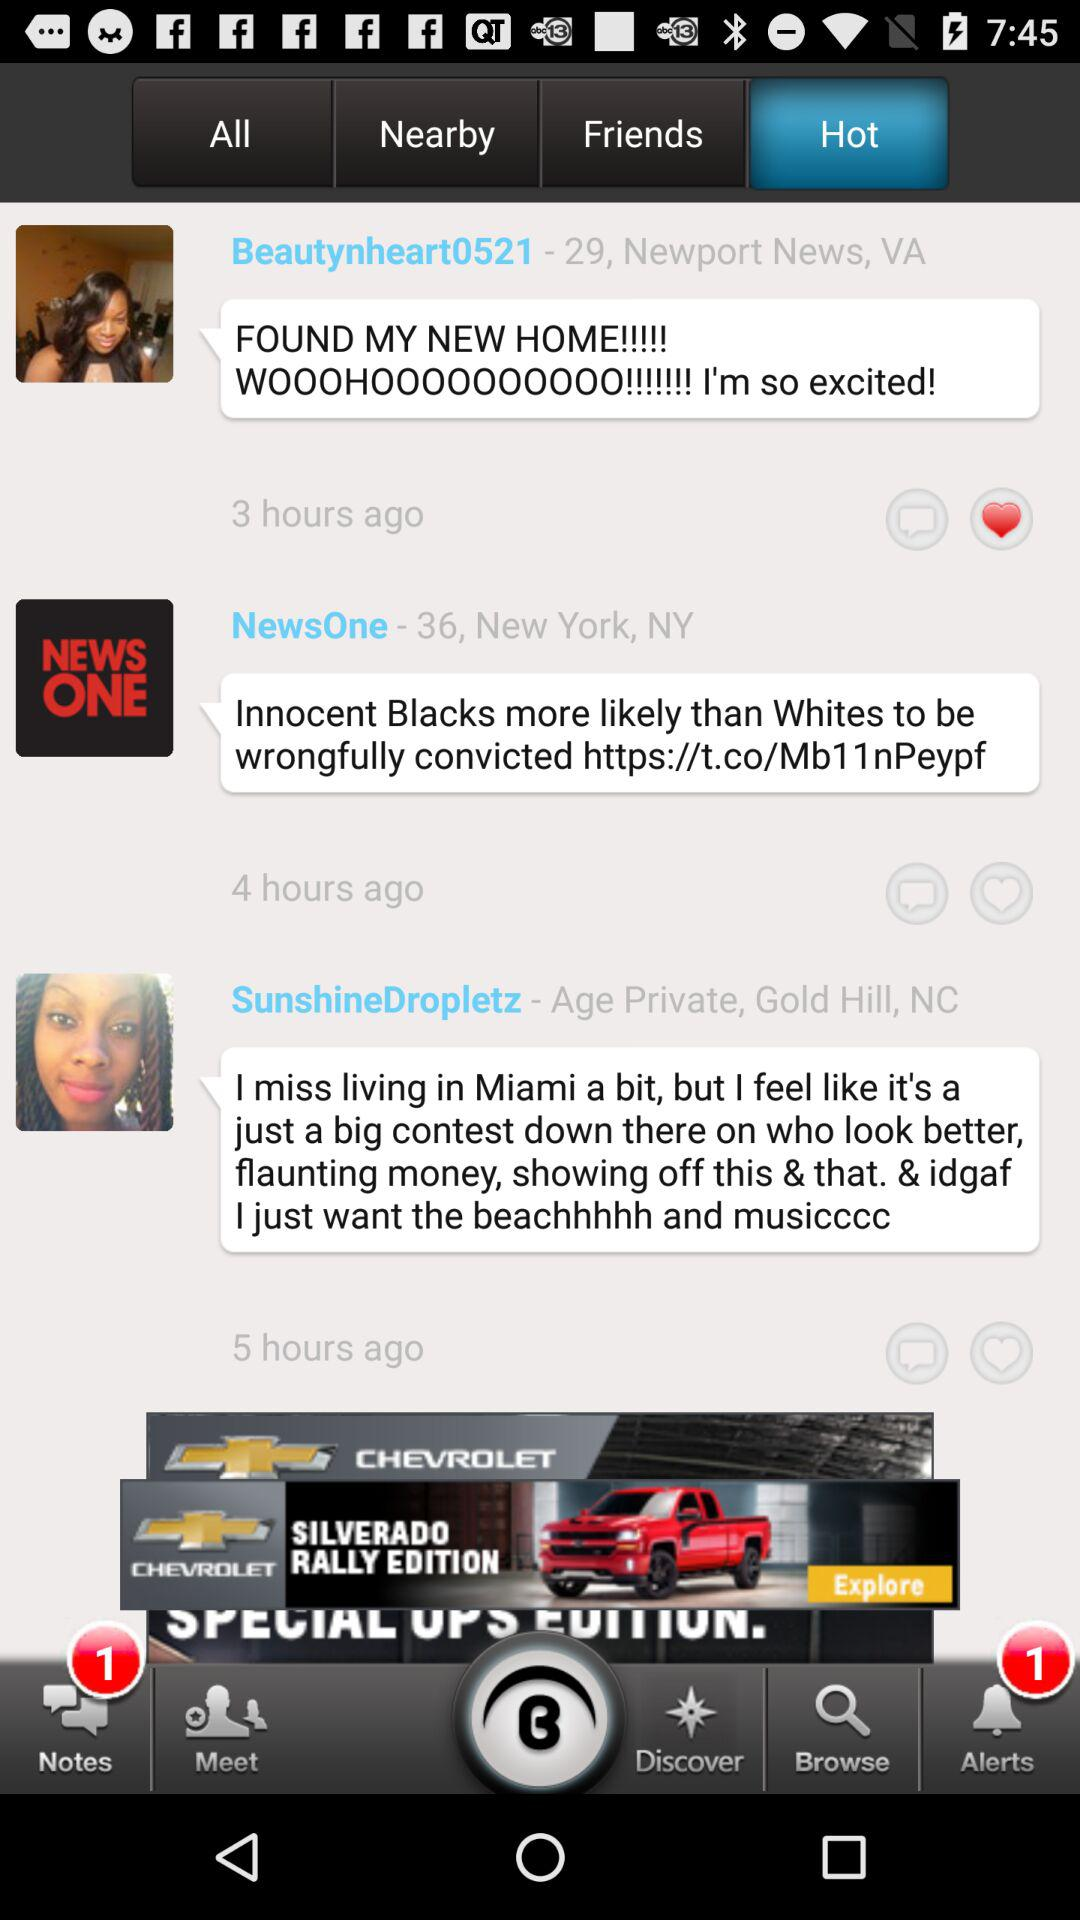What is the age of "Beautynheart0521"? The age of "Beautynheart0521" is 29. 